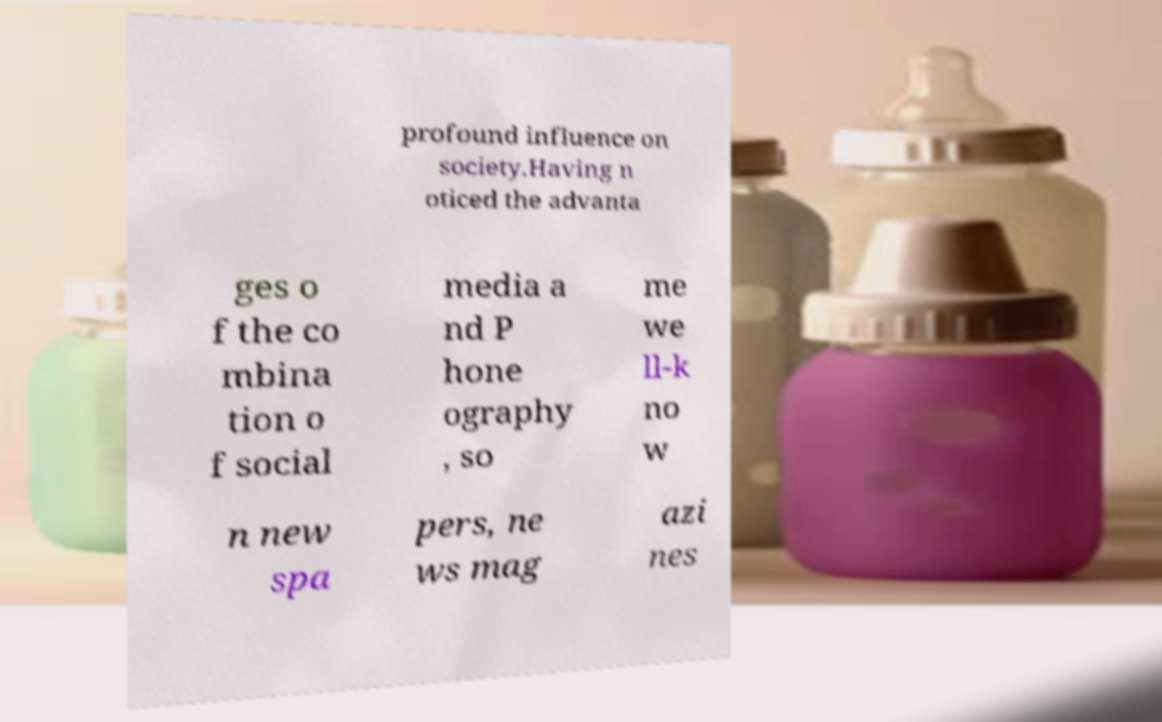I need the written content from this picture converted into text. Can you do that? profound influence on society.Having n oticed the advanta ges o f the co mbina tion o f social media a nd P hone ography , so me we ll-k no w n new spa pers, ne ws mag azi nes 